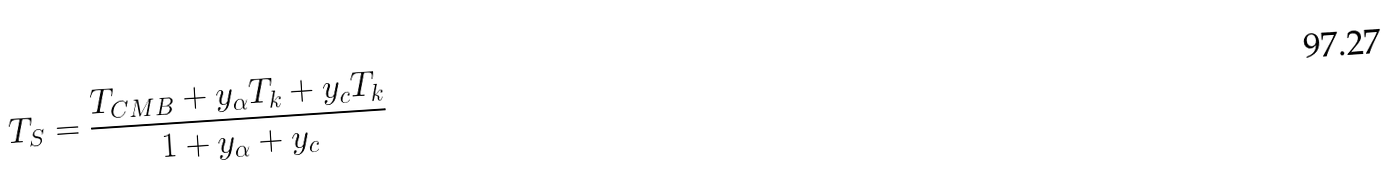Convert formula to latex. <formula><loc_0><loc_0><loc_500><loc_500>T _ { S } = \frac { T _ { C M B } + y _ { \alpha } T _ { k } + y _ { c } T _ { k } } { 1 + y _ { \alpha } + y _ { c } }</formula> 